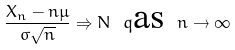Convert formula to latex. <formula><loc_0><loc_0><loc_500><loc_500>\frac { X _ { n } - n \mu } { \sigma \sqrt { n } } \Rightarrow N \ q \text {as} \ n \to \infty</formula> 